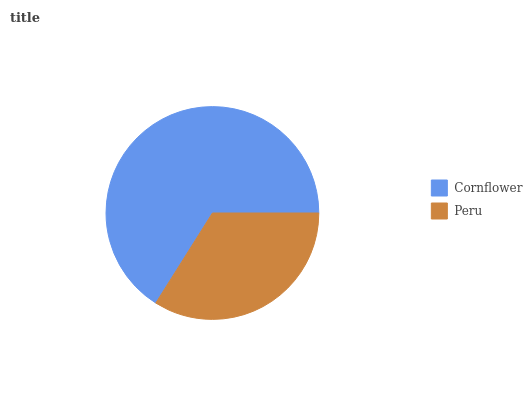Is Peru the minimum?
Answer yes or no. Yes. Is Cornflower the maximum?
Answer yes or no. Yes. Is Peru the maximum?
Answer yes or no. No. Is Cornflower greater than Peru?
Answer yes or no. Yes. Is Peru less than Cornflower?
Answer yes or no. Yes. Is Peru greater than Cornflower?
Answer yes or no. No. Is Cornflower less than Peru?
Answer yes or no. No. Is Cornflower the high median?
Answer yes or no. Yes. Is Peru the low median?
Answer yes or no. Yes. Is Peru the high median?
Answer yes or no. No. Is Cornflower the low median?
Answer yes or no. No. 